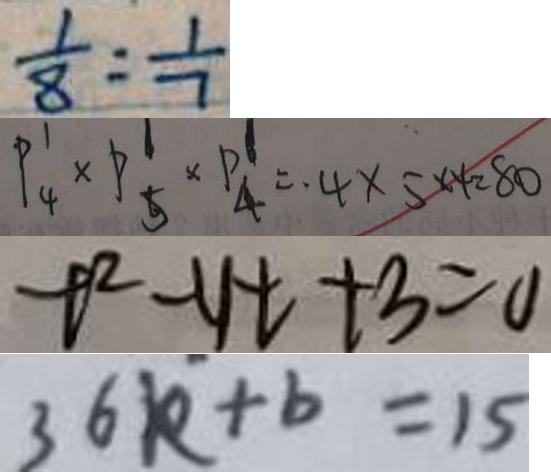Convert formula to latex. <formula><loc_0><loc_0><loc_500><loc_500>\frac { 1 } { 8 } : \frac { 1 } { 7 } 
 P ^ { 1 } _ { 4 } \times P ^ { 1 } _ { 5 } \times P ^ { 1 } _ { 4 } = 4 \times 5 \times 4 = 8 0 
 t ^ { 2 } - y t + 3 = 0 
 3 6 k + b = 1 5</formula> 